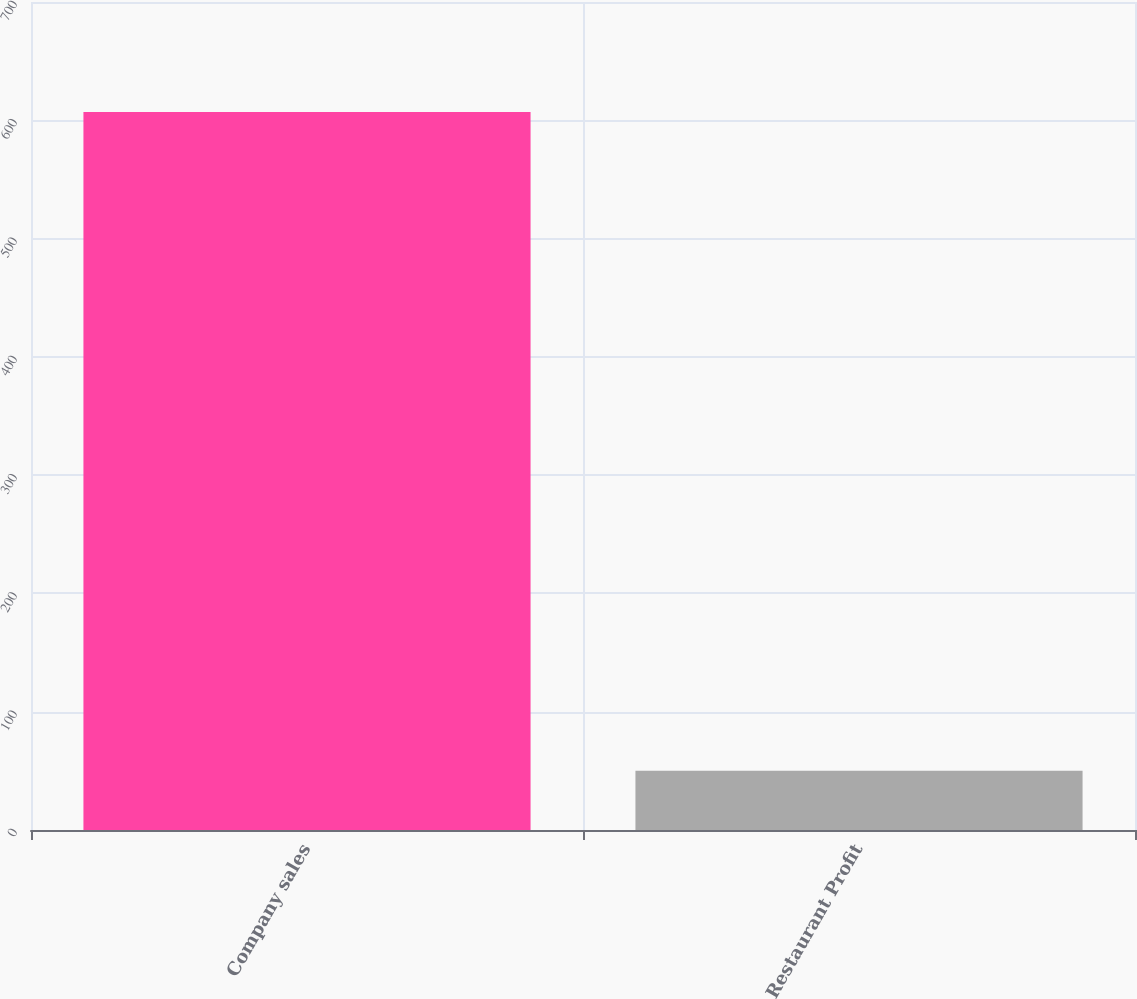<chart> <loc_0><loc_0><loc_500><loc_500><bar_chart><fcel>Company sales<fcel>Restaurant Profit<nl><fcel>607<fcel>50<nl></chart> 